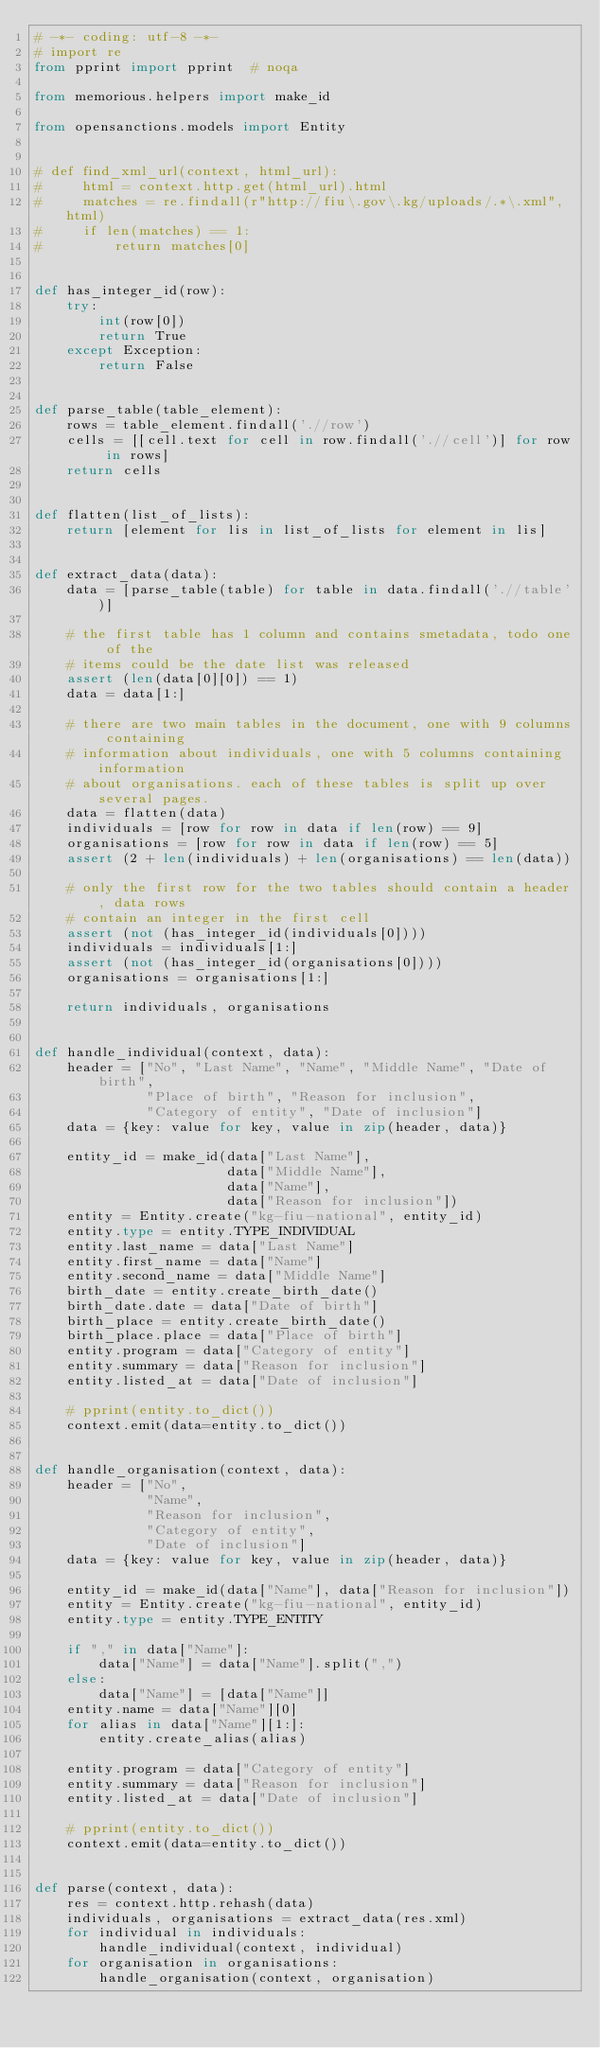<code> <loc_0><loc_0><loc_500><loc_500><_Python_># -*- coding: utf-8 -*-
# import re
from pprint import pprint  # noqa

from memorious.helpers import make_id

from opensanctions.models import Entity


# def find_xml_url(context, html_url):
#     html = context.http.get(html_url).html
#     matches = re.findall(r"http://fiu\.gov\.kg/uploads/.*\.xml", html)
#     if len(matches) == 1:
#         return matches[0]


def has_integer_id(row):
    try:
        int(row[0])
        return True
    except Exception:
        return False


def parse_table(table_element):
    rows = table_element.findall('.//row')
    cells = [[cell.text for cell in row.findall('.//cell')] for row in rows]
    return cells


def flatten(list_of_lists):
    return [element for lis in list_of_lists for element in lis]


def extract_data(data):
    data = [parse_table(table) for table in data.findall('.//table')]

    # the first table has 1 column and contains smetadata, todo one of the
    # items could be the date list was released
    assert (len(data[0][0]) == 1)
    data = data[1:]

    # there are two main tables in the document, one with 9 columns containing
    # information about individuals, one with 5 columns containing information
    # about organisations. each of these tables is split up over several pages.
    data = flatten(data)
    individuals = [row for row in data if len(row) == 9]
    organisations = [row for row in data if len(row) == 5]
    assert (2 + len(individuals) + len(organisations) == len(data))

    # only the first row for the two tables should contain a header, data rows
    # contain an integer in the first cell
    assert (not (has_integer_id(individuals[0])))
    individuals = individuals[1:]
    assert (not (has_integer_id(organisations[0])))
    organisations = organisations[1:]

    return individuals, organisations


def handle_individual(context, data):
    header = ["No", "Last Name", "Name", "Middle Name", "Date of birth",
              "Place of birth", "Reason for inclusion",
              "Category of entity", "Date of inclusion"]
    data = {key: value for key, value in zip(header, data)}

    entity_id = make_id(data["Last Name"],
                        data["Middle Name"],
                        data["Name"],
                        data["Reason for inclusion"])
    entity = Entity.create("kg-fiu-national", entity_id)
    entity.type = entity.TYPE_INDIVIDUAL
    entity.last_name = data["Last Name"]
    entity.first_name = data["Name"]
    entity.second_name = data["Middle Name"]
    birth_date = entity.create_birth_date()
    birth_date.date = data["Date of birth"]
    birth_place = entity.create_birth_date()
    birth_place.place = data["Place of birth"]
    entity.program = data["Category of entity"]
    entity.summary = data["Reason for inclusion"]
    entity.listed_at = data["Date of inclusion"]

    # pprint(entity.to_dict())
    context.emit(data=entity.to_dict())


def handle_organisation(context, data):
    header = ["No",
              "Name",
              "Reason for inclusion",
              "Category of entity",
              "Date of inclusion"]
    data = {key: value for key, value in zip(header, data)}

    entity_id = make_id(data["Name"], data["Reason for inclusion"])
    entity = Entity.create("kg-fiu-national", entity_id)
    entity.type = entity.TYPE_ENTITY

    if "," in data["Name"]:
        data["Name"] = data["Name"].split(",")
    else:
        data["Name"] = [data["Name"]]
    entity.name = data["Name"][0]
    for alias in data["Name"][1:]:
        entity.create_alias(alias)

    entity.program = data["Category of entity"]
    entity.summary = data["Reason for inclusion"]
    entity.listed_at = data["Date of inclusion"]

    # pprint(entity.to_dict())
    context.emit(data=entity.to_dict())


def parse(context, data):
    res = context.http.rehash(data)
    individuals, organisations = extract_data(res.xml)
    for individual in individuals:
        handle_individual(context, individual)
    for organisation in organisations:
        handle_organisation(context, organisation)
</code> 